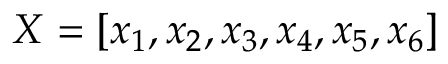Convert formula to latex. <formula><loc_0><loc_0><loc_500><loc_500>X = [ x _ { 1 } , x _ { 2 } , x _ { 3 } , x _ { 4 } , x _ { 5 } , x _ { 6 } ]</formula> 